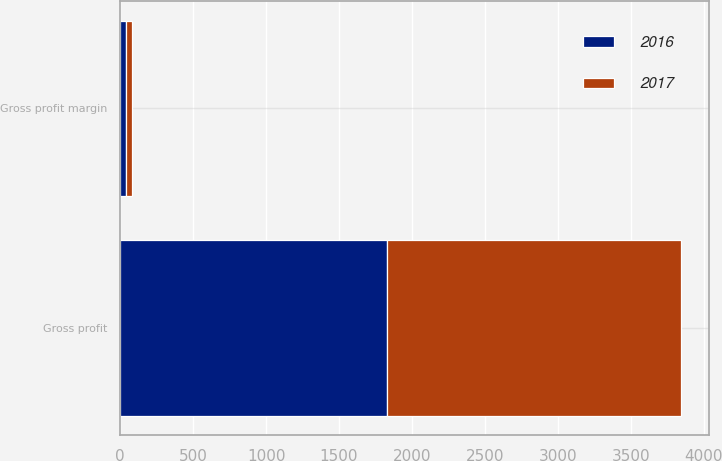<chart> <loc_0><loc_0><loc_500><loc_500><stacked_bar_chart><ecel><fcel>Gross profit<fcel>Gross profit margin<nl><fcel>2017<fcel>2010.2<fcel>41.6<nl><fcel>2016<fcel>1831.7<fcel>41.5<nl></chart> 